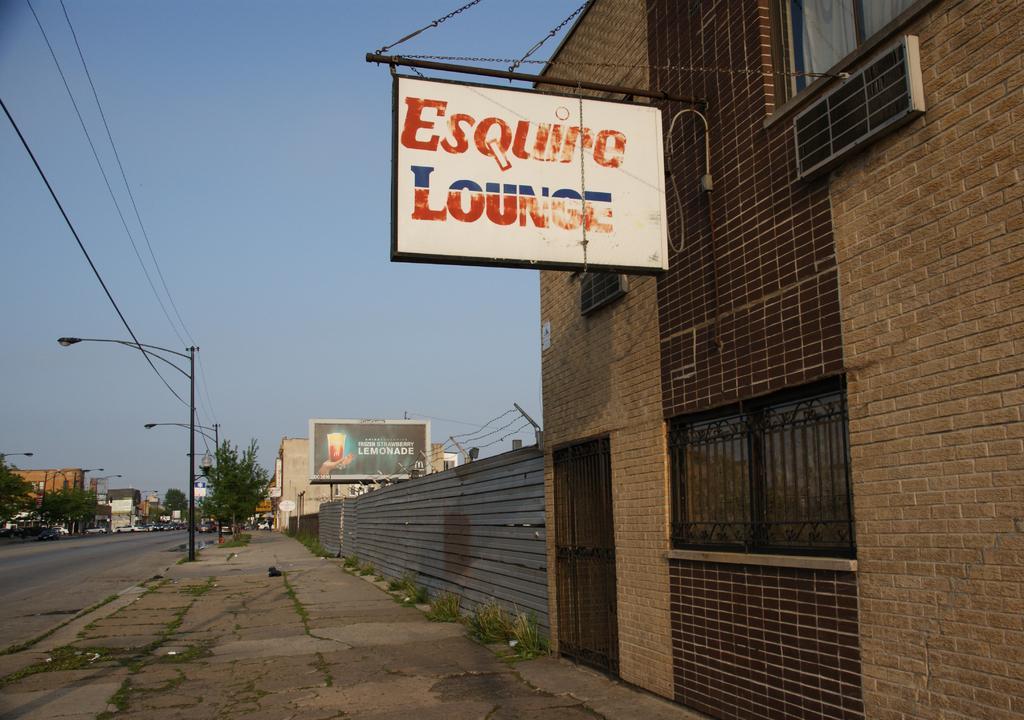Please provide a concise description of this image. This picture is clicked outside the city. On the right side, we see a building in brown color. We see a board in white color with some text written on it. Beside that, we see a fence. There are street lights, wires and electric poles. There are trees and buildings in the background. We even see cars moving on the road. At the top of the picture, we see the sky. 